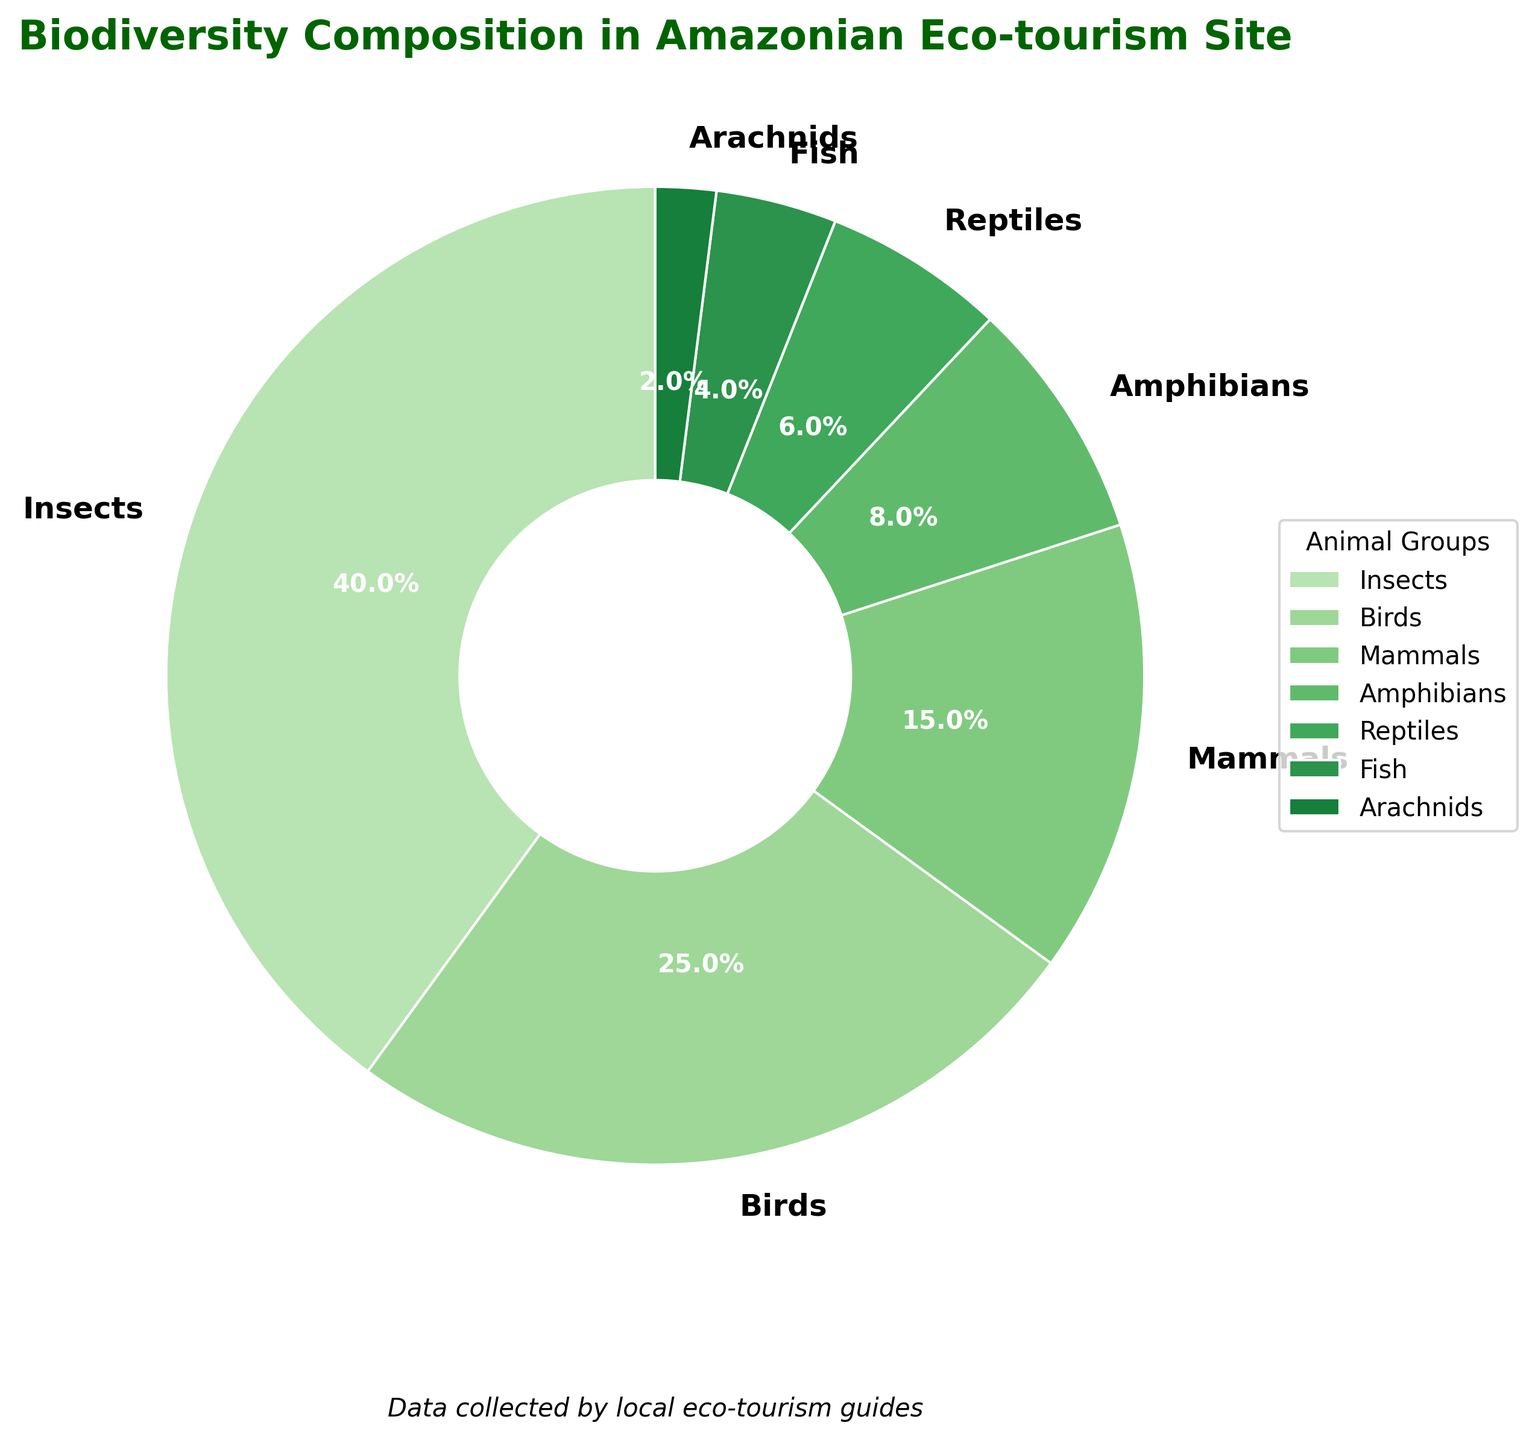What animal group accounts for the largest percentage of biodiversity in the Amazonian eco-tourism site? The largest percentage can be identified by looking at the segment with the greatest size in the pie chart. According to the data, insects account for 40% which is the largest percentage.
Answer: Insects Which animal group has the smallest representation on the eco-tourism site? The smallest segment of the pie chart represents the group with the smallest percentage. According to the data, Arachnids account for 2%, which is the smallest percentage.
Answer: Arachnids Are there more birds or amphibians in the site? Comparing the sizes of the segments labeled "Birds" (25%) and "Amphibians" (8%), birds have a larger percentage.
Answer: Birds What is the cumulative percentage of mammals, amphibians, and reptiles? Adding the percentages of the three groups: Mammals (15%) + Amphibians (8%) + Reptiles (6%) gives 29%.
Answer: 29% What is the difference in percentage between insects and fish? Subtract the percentage of fish from the percentage of insects: 40% (Insects) - 4% (Fish) = 36%.
Answer: 36% What percentage of the biodiversity is accounted for by non-insect groups? Sum the percentages of all groups except insects: 25% (Birds) + 15% (Mammals) + 8% (Amphibians) + 6% (Reptiles) + 4% (Fish) + 2% (Arachnids) = 60%.
Answer: 60% Which animal group is represented by a green segment closest to the center of the chart? The pie chart's structure places the group with the smallest percentage closest to the center. Since Arachnids have 2%, they are represented by the green center segment.
Answer: Arachnids How much larger is the percentage of birds compared to that of reptiles? Subtract the percentage of reptiles from birds: 25% (Birds) - 6% (Reptiles) = 19%.
Answer: 19% What animal group comprises a quarter of the biodiversity at the site? Identify the group with a 25% representation, which corresponds to a quarter of the pie. According to the data, birds represent 25%.
Answer: Birds 